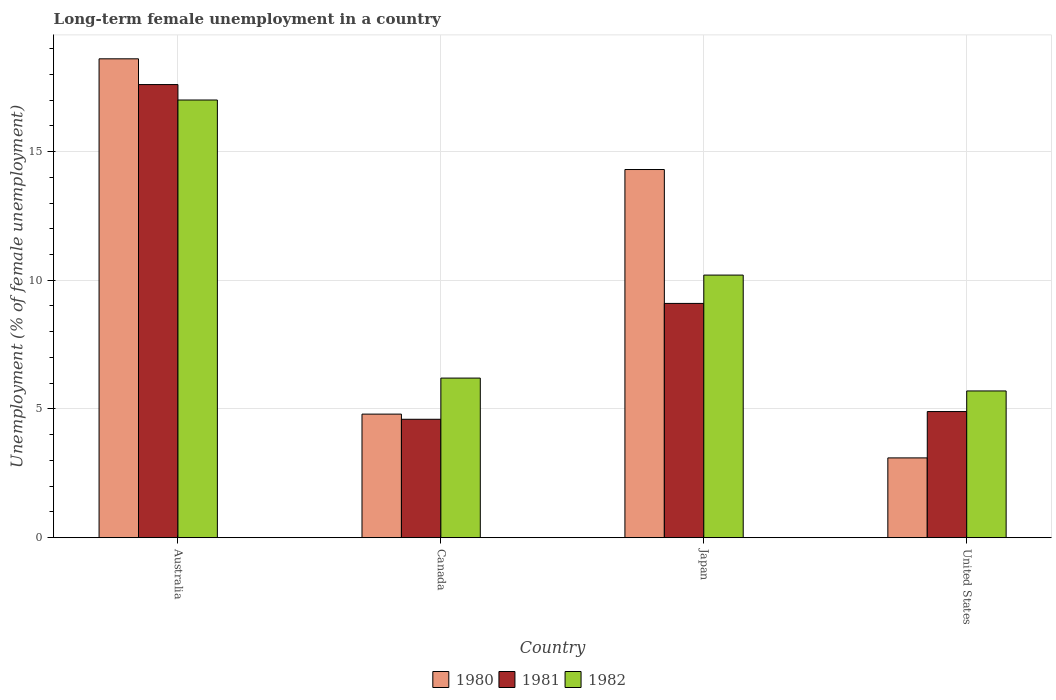How many different coloured bars are there?
Offer a very short reply. 3. How many groups of bars are there?
Ensure brevity in your answer.  4. What is the label of the 4th group of bars from the left?
Your answer should be compact. United States. In how many cases, is the number of bars for a given country not equal to the number of legend labels?
Your answer should be compact. 0. What is the percentage of long-term unemployed female population in 1982 in Canada?
Make the answer very short. 6.2. Across all countries, what is the maximum percentage of long-term unemployed female population in 1981?
Ensure brevity in your answer.  17.6. Across all countries, what is the minimum percentage of long-term unemployed female population in 1981?
Provide a short and direct response. 4.6. In which country was the percentage of long-term unemployed female population in 1981 maximum?
Ensure brevity in your answer.  Australia. In which country was the percentage of long-term unemployed female population in 1982 minimum?
Your answer should be compact. United States. What is the total percentage of long-term unemployed female population in 1981 in the graph?
Offer a very short reply. 36.2. What is the difference between the percentage of long-term unemployed female population in 1980 in Canada and that in Japan?
Give a very brief answer. -9.5. What is the difference between the percentage of long-term unemployed female population in 1981 in United States and the percentage of long-term unemployed female population in 1980 in Japan?
Make the answer very short. -9.4. What is the average percentage of long-term unemployed female population in 1981 per country?
Offer a very short reply. 9.05. What is the difference between the percentage of long-term unemployed female population of/in 1981 and percentage of long-term unemployed female population of/in 1982 in United States?
Offer a terse response. -0.8. In how many countries, is the percentage of long-term unemployed female population in 1982 greater than 9 %?
Offer a terse response. 2. What is the ratio of the percentage of long-term unemployed female population in 1982 in Australia to that in United States?
Provide a succinct answer. 2.98. Is the percentage of long-term unemployed female population in 1981 in Japan less than that in United States?
Your answer should be compact. No. What is the difference between the highest and the second highest percentage of long-term unemployed female population in 1982?
Your answer should be very brief. 6.8. What is the difference between the highest and the lowest percentage of long-term unemployed female population in 1981?
Your answer should be very brief. 13. In how many countries, is the percentage of long-term unemployed female population in 1982 greater than the average percentage of long-term unemployed female population in 1982 taken over all countries?
Make the answer very short. 2. Is the sum of the percentage of long-term unemployed female population in 1980 in Australia and Japan greater than the maximum percentage of long-term unemployed female population in 1982 across all countries?
Provide a succinct answer. Yes. What does the 1st bar from the left in Japan represents?
Make the answer very short. 1980. What does the 3rd bar from the right in Australia represents?
Offer a very short reply. 1980. Is it the case that in every country, the sum of the percentage of long-term unemployed female population in 1982 and percentage of long-term unemployed female population in 1981 is greater than the percentage of long-term unemployed female population in 1980?
Provide a succinct answer. Yes. How many bars are there?
Ensure brevity in your answer.  12. Are all the bars in the graph horizontal?
Keep it short and to the point. No. How many countries are there in the graph?
Offer a very short reply. 4. Are the values on the major ticks of Y-axis written in scientific E-notation?
Make the answer very short. No. Does the graph contain any zero values?
Offer a terse response. No. Where does the legend appear in the graph?
Your answer should be very brief. Bottom center. How many legend labels are there?
Offer a terse response. 3. What is the title of the graph?
Provide a succinct answer. Long-term female unemployment in a country. What is the label or title of the X-axis?
Make the answer very short. Country. What is the label or title of the Y-axis?
Give a very brief answer. Unemployment (% of female unemployment). What is the Unemployment (% of female unemployment) of 1980 in Australia?
Ensure brevity in your answer.  18.6. What is the Unemployment (% of female unemployment) in 1981 in Australia?
Offer a very short reply. 17.6. What is the Unemployment (% of female unemployment) of 1980 in Canada?
Your response must be concise. 4.8. What is the Unemployment (% of female unemployment) in 1981 in Canada?
Make the answer very short. 4.6. What is the Unemployment (% of female unemployment) of 1982 in Canada?
Give a very brief answer. 6.2. What is the Unemployment (% of female unemployment) of 1980 in Japan?
Provide a short and direct response. 14.3. What is the Unemployment (% of female unemployment) in 1981 in Japan?
Provide a succinct answer. 9.1. What is the Unemployment (% of female unemployment) in 1982 in Japan?
Give a very brief answer. 10.2. What is the Unemployment (% of female unemployment) in 1980 in United States?
Ensure brevity in your answer.  3.1. What is the Unemployment (% of female unemployment) in 1981 in United States?
Keep it short and to the point. 4.9. What is the Unemployment (% of female unemployment) in 1982 in United States?
Provide a short and direct response. 5.7. Across all countries, what is the maximum Unemployment (% of female unemployment) in 1980?
Make the answer very short. 18.6. Across all countries, what is the maximum Unemployment (% of female unemployment) of 1981?
Offer a terse response. 17.6. Across all countries, what is the minimum Unemployment (% of female unemployment) of 1980?
Provide a succinct answer. 3.1. Across all countries, what is the minimum Unemployment (% of female unemployment) in 1981?
Ensure brevity in your answer.  4.6. Across all countries, what is the minimum Unemployment (% of female unemployment) of 1982?
Ensure brevity in your answer.  5.7. What is the total Unemployment (% of female unemployment) in 1980 in the graph?
Offer a terse response. 40.8. What is the total Unemployment (% of female unemployment) of 1981 in the graph?
Your answer should be compact. 36.2. What is the total Unemployment (% of female unemployment) of 1982 in the graph?
Keep it short and to the point. 39.1. What is the difference between the Unemployment (% of female unemployment) of 1980 in Australia and that in Canada?
Offer a terse response. 13.8. What is the difference between the Unemployment (% of female unemployment) of 1980 in Australia and that in Japan?
Offer a terse response. 4.3. What is the difference between the Unemployment (% of female unemployment) of 1981 in Australia and that in Japan?
Provide a succinct answer. 8.5. What is the difference between the Unemployment (% of female unemployment) in 1980 in Australia and that in United States?
Your response must be concise. 15.5. What is the difference between the Unemployment (% of female unemployment) of 1981 in Australia and that in United States?
Offer a terse response. 12.7. What is the difference between the Unemployment (% of female unemployment) in 1982 in Australia and that in United States?
Your answer should be very brief. 11.3. What is the difference between the Unemployment (% of female unemployment) of 1980 in Canada and that in Japan?
Your answer should be very brief. -9.5. What is the difference between the Unemployment (% of female unemployment) in 1981 in Canada and that in Japan?
Provide a succinct answer. -4.5. What is the difference between the Unemployment (% of female unemployment) in 1982 in Canada and that in Japan?
Offer a terse response. -4. What is the difference between the Unemployment (% of female unemployment) of 1981 in Canada and that in United States?
Your answer should be compact. -0.3. What is the difference between the Unemployment (% of female unemployment) of 1981 in Japan and that in United States?
Your answer should be compact. 4.2. What is the difference between the Unemployment (% of female unemployment) in 1982 in Japan and that in United States?
Your answer should be compact. 4.5. What is the difference between the Unemployment (% of female unemployment) in 1980 in Australia and the Unemployment (% of female unemployment) in 1982 in Canada?
Your answer should be very brief. 12.4. What is the difference between the Unemployment (% of female unemployment) of 1981 in Australia and the Unemployment (% of female unemployment) of 1982 in Canada?
Keep it short and to the point. 11.4. What is the difference between the Unemployment (% of female unemployment) of 1980 in Australia and the Unemployment (% of female unemployment) of 1981 in Japan?
Ensure brevity in your answer.  9.5. What is the difference between the Unemployment (% of female unemployment) of 1980 in Australia and the Unemployment (% of female unemployment) of 1982 in Japan?
Give a very brief answer. 8.4. What is the difference between the Unemployment (% of female unemployment) of 1981 in Australia and the Unemployment (% of female unemployment) of 1982 in United States?
Offer a very short reply. 11.9. What is the difference between the Unemployment (% of female unemployment) of 1980 in Canada and the Unemployment (% of female unemployment) of 1981 in Japan?
Offer a terse response. -4.3. What is the difference between the Unemployment (% of female unemployment) in 1980 in Canada and the Unemployment (% of female unemployment) in 1982 in Japan?
Provide a short and direct response. -5.4. What is the difference between the Unemployment (% of female unemployment) of 1981 in Canada and the Unemployment (% of female unemployment) of 1982 in Japan?
Your answer should be compact. -5.6. What is the difference between the Unemployment (% of female unemployment) in 1980 in Canada and the Unemployment (% of female unemployment) in 1981 in United States?
Provide a succinct answer. -0.1. What is the difference between the Unemployment (% of female unemployment) in 1980 in Japan and the Unemployment (% of female unemployment) in 1982 in United States?
Your answer should be compact. 8.6. What is the difference between the Unemployment (% of female unemployment) of 1981 in Japan and the Unemployment (% of female unemployment) of 1982 in United States?
Provide a short and direct response. 3.4. What is the average Unemployment (% of female unemployment) of 1981 per country?
Keep it short and to the point. 9.05. What is the average Unemployment (% of female unemployment) of 1982 per country?
Offer a terse response. 9.78. What is the difference between the Unemployment (% of female unemployment) of 1980 and Unemployment (% of female unemployment) of 1981 in Japan?
Your answer should be very brief. 5.2. What is the difference between the Unemployment (% of female unemployment) of 1980 and Unemployment (% of female unemployment) of 1982 in Japan?
Your answer should be very brief. 4.1. What is the difference between the Unemployment (% of female unemployment) in 1981 and Unemployment (% of female unemployment) in 1982 in Japan?
Your answer should be very brief. -1.1. What is the difference between the Unemployment (% of female unemployment) of 1981 and Unemployment (% of female unemployment) of 1982 in United States?
Keep it short and to the point. -0.8. What is the ratio of the Unemployment (% of female unemployment) in 1980 in Australia to that in Canada?
Offer a terse response. 3.88. What is the ratio of the Unemployment (% of female unemployment) in 1981 in Australia to that in Canada?
Offer a very short reply. 3.83. What is the ratio of the Unemployment (% of female unemployment) in 1982 in Australia to that in Canada?
Your response must be concise. 2.74. What is the ratio of the Unemployment (% of female unemployment) of 1980 in Australia to that in Japan?
Offer a very short reply. 1.3. What is the ratio of the Unemployment (% of female unemployment) of 1981 in Australia to that in Japan?
Keep it short and to the point. 1.93. What is the ratio of the Unemployment (% of female unemployment) in 1981 in Australia to that in United States?
Offer a very short reply. 3.59. What is the ratio of the Unemployment (% of female unemployment) in 1982 in Australia to that in United States?
Ensure brevity in your answer.  2.98. What is the ratio of the Unemployment (% of female unemployment) in 1980 in Canada to that in Japan?
Offer a very short reply. 0.34. What is the ratio of the Unemployment (% of female unemployment) of 1981 in Canada to that in Japan?
Provide a short and direct response. 0.51. What is the ratio of the Unemployment (% of female unemployment) of 1982 in Canada to that in Japan?
Keep it short and to the point. 0.61. What is the ratio of the Unemployment (% of female unemployment) in 1980 in Canada to that in United States?
Offer a very short reply. 1.55. What is the ratio of the Unemployment (% of female unemployment) of 1981 in Canada to that in United States?
Make the answer very short. 0.94. What is the ratio of the Unemployment (% of female unemployment) in 1982 in Canada to that in United States?
Provide a succinct answer. 1.09. What is the ratio of the Unemployment (% of female unemployment) of 1980 in Japan to that in United States?
Provide a succinct answer. 4.61. What is the ratio of the Unemployment (% of female unemployment) in 1981 in Japan to that in United States?
Ensure brevity in your answer.  1.86. What is the ratio of the Unemployment (% of female unemployment) of 1982 in Japan to that in United States?
Provide a short and direct response. 1.79. What is the difference between the highest and the second highest Unemployment (% of female unemployment) in 1980?
Ensure brevity in your answer.  4.3. What is the difference between the highest and the second highest Unemployment (% of female unemployment) in 1982?
Your answer should be very brief. 6.8. What is the difference between the highest and the lowest Unemployment (% of female unemployment) of 1980?
Provide a short and direct response. 15.5. 